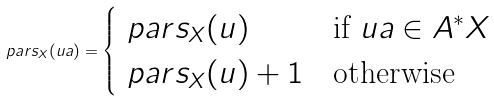<formula> <loc_0><loc_0><loc_500><loc_500>\ p a r s _ { X } ( u a ) = \begin{cases} \ p a r s _ { X } ( u ) & \text {if } u a \in A ^ { * } X \\ \ p a r s _ { X } ( u ) + 1 & \text {otherwise} \end{cases}</formula> 